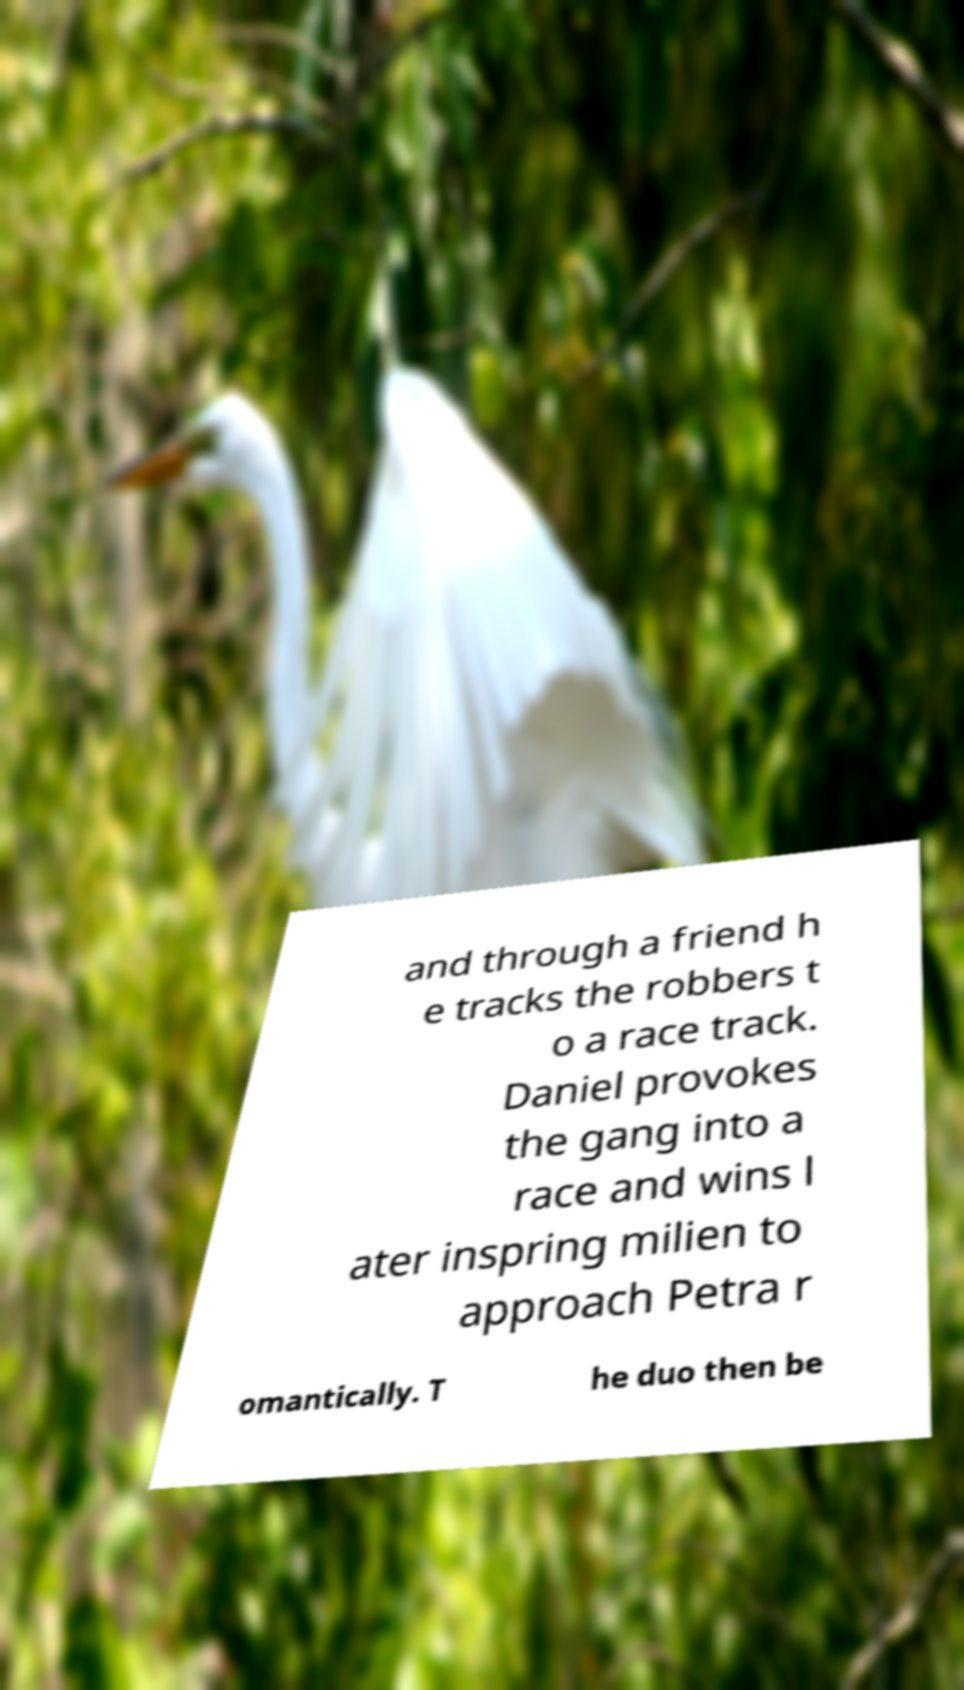What messages or text are displayed in this image? I need them in a readable, typed format. and through a friend h e tracks the robbers t o a race track. Daniel provokes the gang into a race and wins l ater inspring milien to approach Petra r omantically. T he duo then be 